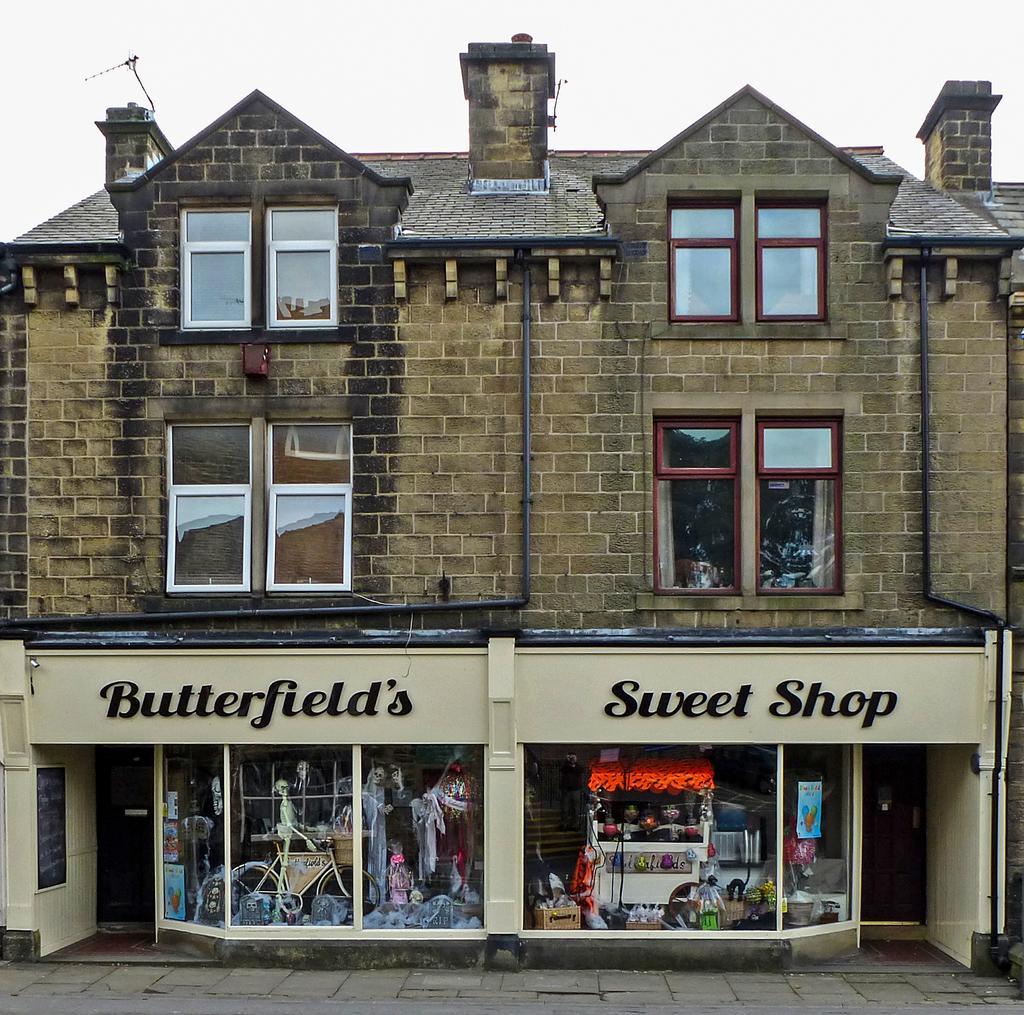Can you describe this image briefly? In this image, we can see a building with walls, pipes, glass windows, pillars. At the bottom, we can see two shops. Here there is a glass wall. Through the glass wall, we can see so many things and objects. Here there is a footpath. 